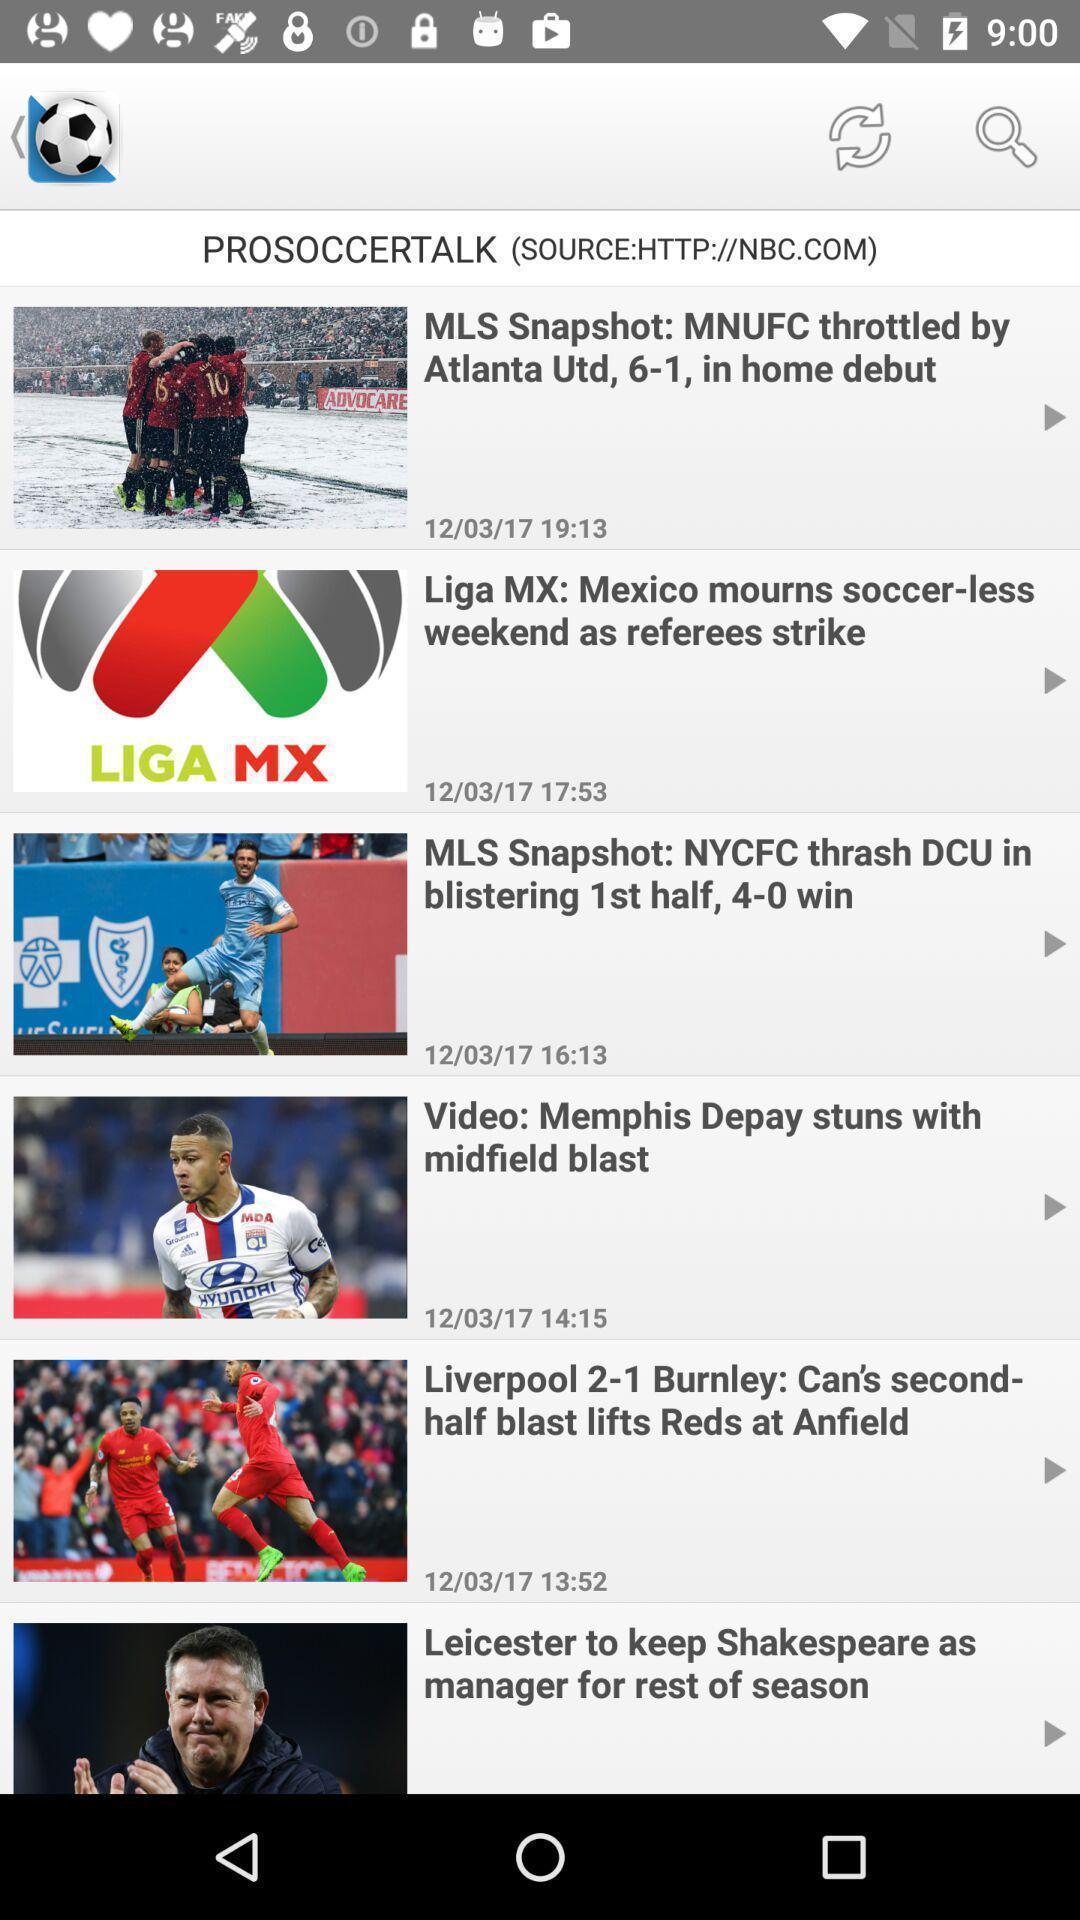Describe the content in this image. Screen shows multiple articles in a sports application. 